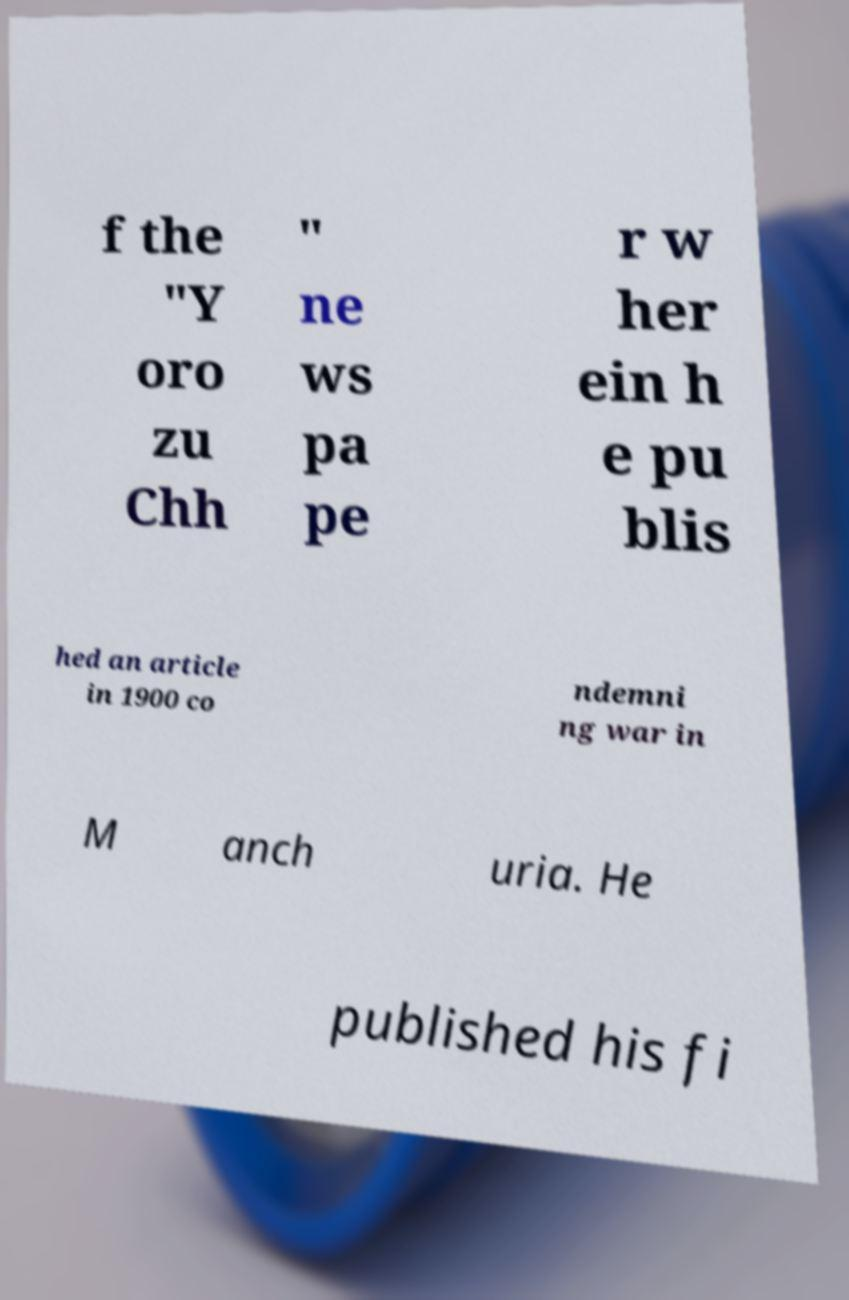Please identify and transcribe the text found in this image. f the "Y oro zu Chh " ne ws pa pe r w her ein h e pu blis hed an article in 1900 co ndemni ng war in M anch uria. He published his fi 